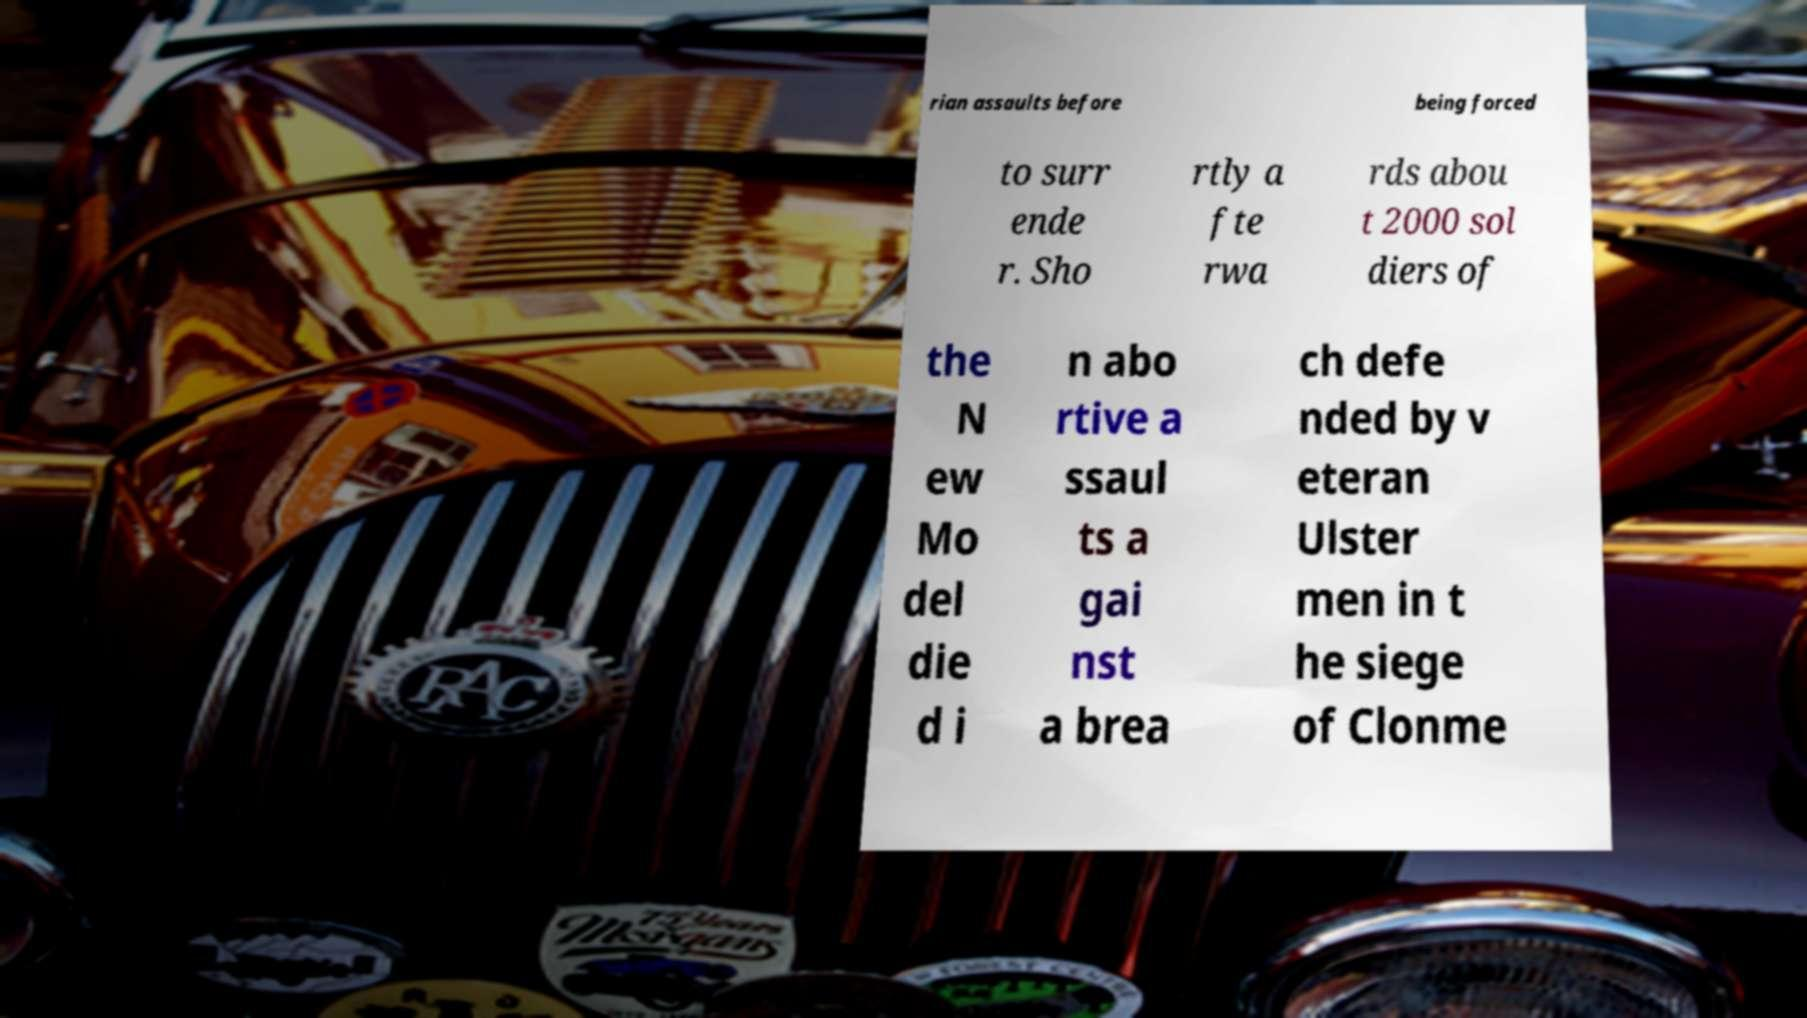Could you extract and type out the text from this image? rian assaults before being forced to surr ende r. Sho rtly a fte rwa rds abou t 2000 sol diers of the N ew Mo del die d i n abo rtive a ssaul ts a gai nst a brea ch defe nded by v eteran Ulster men in t he siege of Clonme 